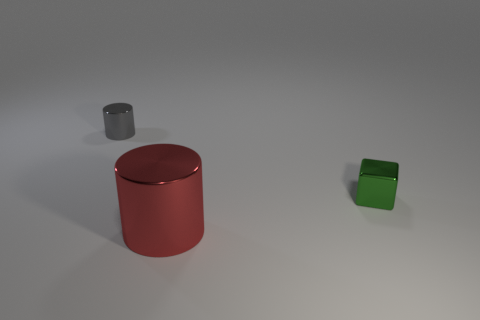Add 1 large cylinders. How many objects exist? 4 Subtract all blocks. How many objects are left? 2 Subtract all small green matte cylinders. Subtract all big metallic things. How many objects are left? 2 Add 3 tiny green shiny objects. How many tiny green shiny objects are left? 4 Add 1 tiny green metallic objects. How many tiny green metallic objects exist? 2 Subtract 0 gray spheres. How many objects are left? 3 